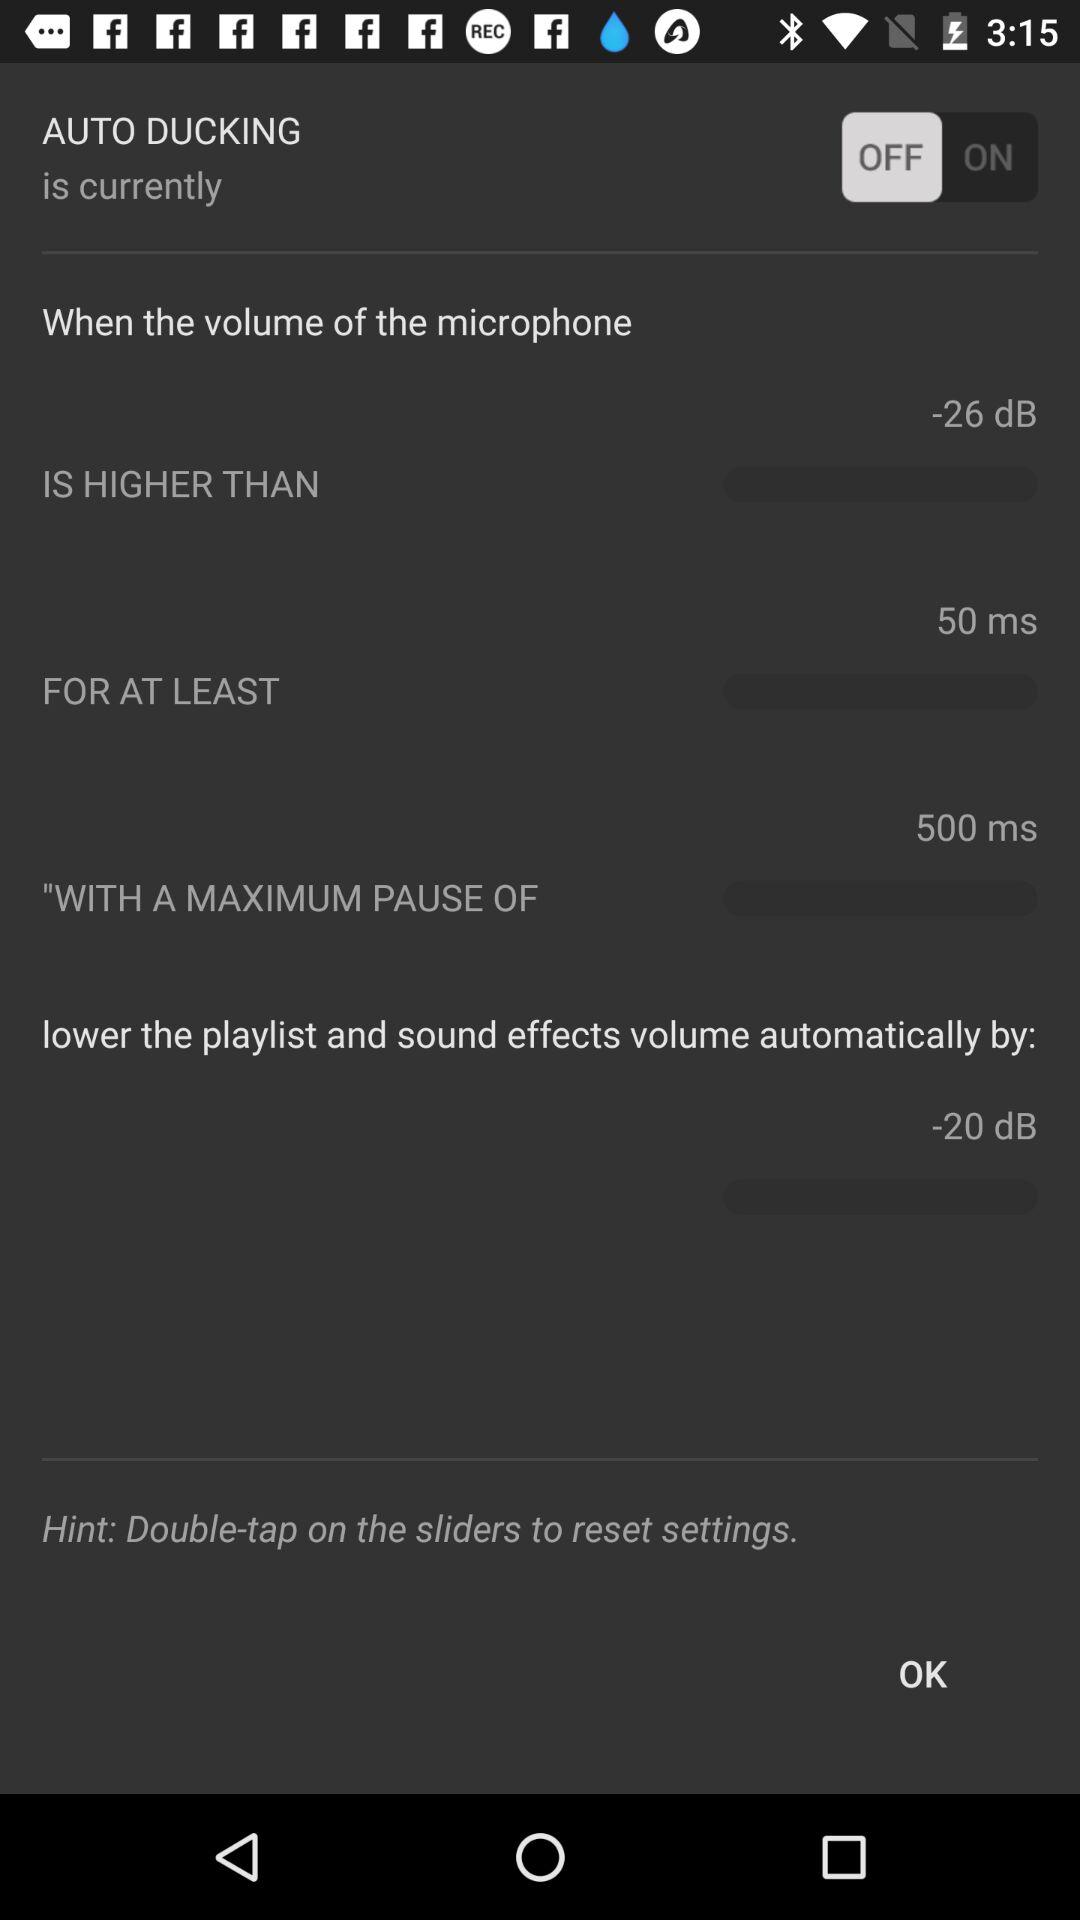What is the time for which the volume is higher than -26dB? The time for which the volume is higher than -26dB is 50 ms. 